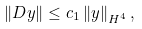<formula> <loc_0><loc_0><loc_500><loc_500>\left \| D y \right \| \leq c _ { 1 } \left \| y \right \| _ { H ^ { 4 } } ,</formula> 